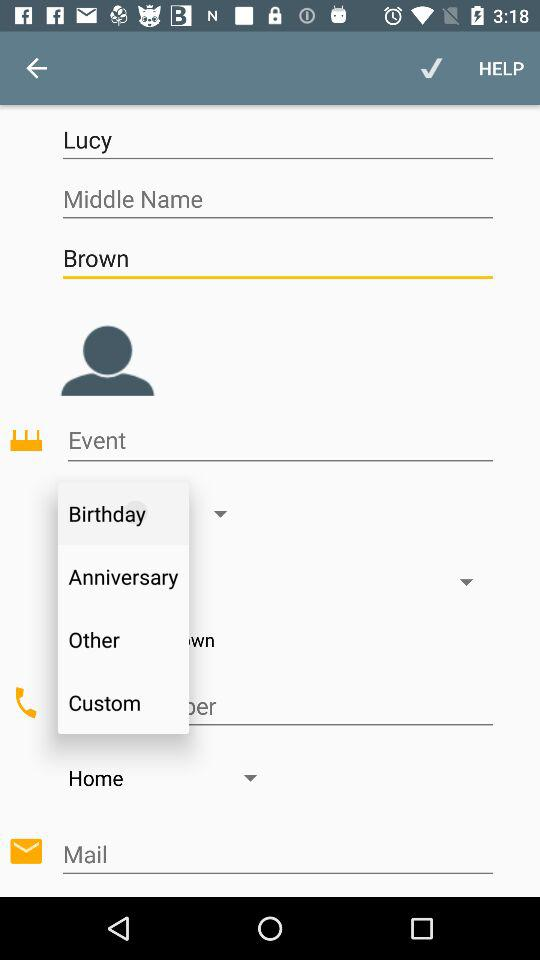Which event is selected?
When the provided information is insufficient, respond with <no answer>. <no answer> 